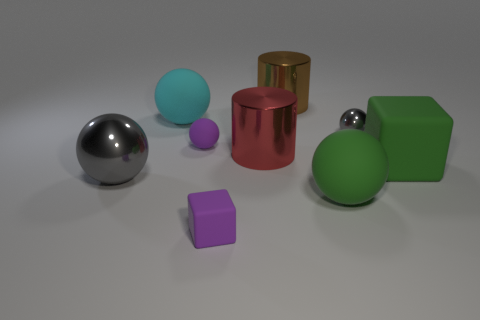How many other objects are there of the same shape as the red metallic thing?
Your response must be concise. 1. The small object that is both behind the large green matte block and to the left of the large brown object is what color?
Provide a succinct answer. Purple. Is the color of the large matte sphere right of the cyan sphere the same as the big block?
Give a very brief answer. Yes. What number of blocks are large rubber things or red matte objects?
Ensure brevity in your answer.  1. There is a gray thing that is left of the tiny gray shiny sphere; what is its shape?
Make the answer very short. Sphere. What color is the big metallic thing that is in front of the green rubber thing right of the gray thing that is behind the green block?
Your answer should be compact. Gray. Are the cyan thing and the big brown object made of the same material?
Offer a very short reply. No. How many red objects are either rubber balls or small metallic balls?
Provide a short and direct response. 0. What number of spheres are to the left of the large cyan sphere?
Make the answer very short. 1. Is the number of rubber cubes greater than the number of large gray objects?
Keep it short and to the point. Yes. 